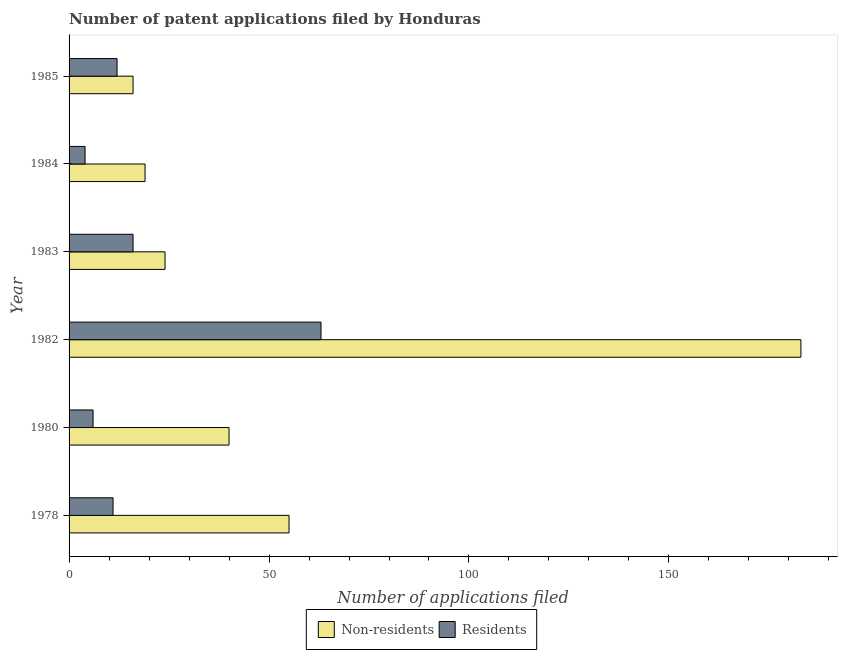How many different coloured bars are there?
Provide a succinct answer. 2. How many groups of bars are there?
Offer a very short reply. 6. How many bars are there on the 2nd tick from the bottom?
Offer a terse response. 2. In how many cases, is the number of bars for a given year not equal to the number of legend labels?
Provide a succinct answer. 0. What is the number of patent applications by non residents in 1984?
Your answer should be very brief. 19. Across all years, what is the maximum number of patent applications by non residents?
Make the answer very short. 183. Across all years, what is the minimum number of patent applications by residents?
Provide a succinct answer. 4. In which year was the number of patent applications by non residents minimum?
Your response must be concise. 1985. What is the total number of patent applications by residents in the graph?
Offer a very short reply. 112. What is the difference between the number of patent applications by residents in 1980 and that in 1985?
Keep it short and to the point. -6. What is the difference between the number of patent applications by residents in 1985 and the number of patent applications by non residents in 1983?
Your answer should be very brief. -12. What is the average number of patent applications by non residents per year?
Make the answer very short. 56.17. In the year 1984, what is the difference between the number of patent applications by non residents and number of patent applications by residents?
Your answer should be very brief. 15. What is the ratio of the number of patent applications by residents in 1982 to that in 1983?
Your response must be concise. 3.94. Is the number of patent applications by non residents in 1980 less than that in 1983?
Offer a very short reply. No. Is the difference between the number of patent applications by residents in 1982 and 1983 greater than the difference between the number of patent applications by non residents in 1982 and 1983?
Offer a very short reply. No. What is the difference between the highest and the lowest number of patent applications by non residents?
Your answer should be compact. 167. In how many years, is the number of patent applications by non residents greater than the average number of patent applications by non residents taken over all years?
Give a very brief answer. 1. What does the 2nd bar from the top in 1980 represents?
Offer a terse response. Non-residents. What does the 1st bar from the bottom in 1983 represents?
Your answer should be compact. Non-residents. How many bars are there?
Offer a terse response. 12. How many years are there in the graph?
Your answer should be very brief. 6. Does the graph contain any zero values?
Your answer should be very brief. No. Does the graph contain grids?
Make the answer very short. No. How many legend labels are there?
Give a very brief answer. 2. How are the legend labels stacked?
Provide a short and direct response. Horizontal. What is the title of the graph?
Your response must be concise. Number of patent applications filed by Honduras. Does "ODA received" appear as one of the legend labels in the graph?
Ensure brevity in your answer.  No. What is the label or title of the X-axis?
Offer a very short reply. Number of applications filed. What is the label or title of the Y-axis?
Give a very brief answer. Year. What is the Number of applications filed of Non-residents in 1978?
Give a very brief answer. 55. What is the Number of applications filed of Non-residents in 1980?
Your response must be concise. 40. What is the Number of applications filed of Non-residents in 1982?
Make the answer very short. 183. What is the Number of applications filed of Non-residents in 1983?
Provide a short and direct response. 24. What is the Number of applications filed in Residents in 1983?
Make the answer very short. 16. What is the Number of applications filed in Non-residents in 1985?
Your response must be concise. 16. What is the Number of applications filed of Residents in 1985?
Offer a very short reply. 12. Across all years, what is the maximum Number of applications filed of Non-residents?
Your answer should be compact. 183. Across all years, what is the minimum Number of applications filed of Non-residents?
Ensure brevity in your answer.  16. What is the total Number of applications filed in Non-residents in the graph?
Your answer should be compact. 337. What is the total Number of applications filed in Residents in the graph?
Give a very brief answer. 112. What is the difference between the Number of applications filed of Non-residents in 1978 and that in 1982?
Make the answer very short. -128. What is the difference between the Number of applications filed of Residents in 1978 and that in 1982?
Make the answer very short. -52. What is the difference between the Number of applications filed in Residents in 1978 and that in 1984?
Offer a very short reply. 7. What is the difference between the Number of applications filed in Non-residents in 1978 and that in 1985?
Your answer should be very brief. 39. What is the difference between the Number of applications filed of Residents in 1978 and that in 1985?
Give a very brief answer. -1. What is the difference between the Number of applications filed in Non-residents in 1980 and that in 1982?
Your answer should be compact. -143. What is the difference between the Number of applications filed of Residents in 1980 and that in 1982?
Offer a terse response. -57. What is the difference between the Number of applications filed in Non-residents in 1980 and that in 1983?
Your response must be concise. 16. What is the difference between the Number of applications filed of Residents in 1980 and that in 1984?
Your response must be concise. 2. What is the difference between the Number of applications filed in Non-residents in 1980 and that in 1985?
Make the answer very short. 24. What is the difference between the Number of applications filed in Non-residents in 1982 and that in 1983?
Offer a very short reply. 159. What is the difference between the Number of applications filed of Residents in 1982 and that in 1983?
Keep it short and to the point. 47. What is the difference between the Number of applications filed of Non-residents in 1982 and that in 1984?
Make the answer very short. 164. What is the difference between the Number of applications filed in Residents in 1982 and that in 1984?
Give a very brief answer. 59. What is the difference between the Number of applications filed in Non-residents in 1982 and that in 1985?
Offer a very short reply. 167. What is the difference between the Number of applications filed in Non-residents in 1983 and that in 1984?
Keep it short and to the point. 5. What is the difference between the Number of applications filed in Non-residents in 1983 and that in 1985?
Provide a short and direct response. 8. What is the difference between the Number of applications filed in Residents in 1983 and that in 1985?
Offer a terse response. 4. What is the difference between the Number of applications filed in Residents in 1984 and that in 1985?
Ensure brevity in your answer.  -8. What is the difference between the Number of applications filed in Non-residents in 1978 and the Number of applications filed in Residents in 1980?
Your response must be concise. 49. What is the difference between the Number of applications filed of Non-residents in 1980 and the Number of applications filed of Residents in 1983?
Keep it short and to the point. 24. What is the difference between the Number of applications filed of Non-residents in 1980 and the Number of applications filed of Residents in 1984?
Your response must be concise. 36. What is the difference between the Number of applications filed in Non-residents in 1980 and the Number of applications filed in Residents in 1985?
Your answer should be compact. 28. What is the difference between the Number of applications filed in Non-residents in 1982 and the Number of applications filed in Residents in 1983?
Provide a short and direct response. 167. What is the difference between the Number of applications filed of Non-residents in 1982 and the Number of applications filed of Residents in 1984?
Make the answer very short. 179. What is the difference between the Number of applications filed of Non-residents in 1982 and the Number of applications filed of Residents in 1985?
Give a very brief answer. 171. What is the difference between the Number of applications filed of Non-residents in 1984 and the Number of applications filed of Residents in 1985?
Provide a succinct answer. 7. What is the average Number of applications filed in Non-residents per year?
Your answer should be very brief. 56.17. What is the average Number of applications filed of Residents per year?
Provide a short and direct response. 18.67. In the year 1978, what is the difference between the Number of applications filed in Non-residents and Number of applications filed in Residents?
Offer a terse response. 44. In the year 1980, what is the difference between the Number of applications filed in Non-residents and Number of applications filed in Residents?
Make the answer very short. 34. In the year 1982, what is the difference between the Number of applications filed of Non-residents and Number of applications filed of Residents?
Keep it short and to the point. 120. In the year 1983, what is the difference between the Number of applications filed in Non-residents and Number of applications filed in Residents?
Keep it short and to the point. 8. What is the ratio of the Number of applications filed of Non-residents in 1978 to that in 1980?
Your answer should be very brief. 1.38. What is the ratio of the Number of applications filed in Residents in 1978 to that in 1980?
Provide a succinct answer. 1.83. What is the ratio of the Number of applications filed of Non-residents in 1978 to that in 1982?
Make the answer very short. 0.3. What is the ratio of the Number of applications filed in Residents in 1978 to that in 1982?
Your response must be concise. 0.17. What is the ratio of the Number of applications filed of Non-residents in 1978 to that in 1983?
Make the answer very short. 2.29. What is the ratio of the Number of applications filed of Residents in 1978 to that in 1983?
Your answer should be compact. 0.69. What is the ratio of the Number of applications filed of Non-residents in 1978 to that in 1984?
Keep it short and to the point. 2.89. What is the ratio of the Number of applications filed in Residents in 1978 to that in 1984?
Give a very brief answer. 2.75. What is the ratio of the Number of applications filed of Non-residents in 1978 to that in 1985?
Provide a succinct answer. 3.44. What is the ratio of the Number of applications filed in Residents in 1978 to that in 1985?
Your answer should be compact. 0.92. What is the ratio of the Number of applications filed in Non-residents in 1980 to that in 1982?
Keep it short and to the point. 0.22. What is the ratio of the Number of applications filed of Residents in 1980 to that in 1982?
Keep it short and to the point. 0.1. What is the ratio of the Number of applications filed in Non-residents in 1980 to that in 1983?
Your response must be concise. 1.67. What is the ratio of the Number of applications filed of Non-residents in 1980 to that in 1984?
Make the answer very short. 2.11. What is the ratio of the Number of applications filed in Residents in 1980 to that in 1984?
Offer a very short reply. 1.5. What is the ratio of the Number of applications filed of Non-residents in 1982 to that in 1983?
Give a very brief answer. 7.62. What is the ratio of the Number of applications filed of Residents in 1982 to that in 1983?
Keep it short and to the point. 3.94. What is the ratio of the Number of applications filed of Non-residents in 1982 to that in 1984?
Your response must be concise. 9.63. What is the ratio of the Number of applications filed of Residents in 1982 to that in 1984?
Keep it short and to the point. 15.75. What is the ratio of the Number of applications filed of Non-residents in 1982 to that in 1985?
Offer a terse response. 11.44. What is the ratio of the Number of applications filed of Residents in 1982 to that in 1985?
Your answer should be very brief. 5.25. What is the ratio of the Number of applications filed of Non-residents in 1983 to that in 1984?
Your response must be concise. 1.26. What is the ratio of the Number of applications filed of Residents in 1983 to that in 1984?
Provide a succinct answer. 4. What is the ratio of the Number of applications filed of Non-residents in 1983 to that in 1985?
Ensure brevity in your answer.  1.5. What is the ratio of the Number of applications filed in Residents in 1983 to that in 1985?
Provide a succinct answer. 1.33. What is the ratio of the Number of applications filed of Non-residents in 1984 to that in 1985?
Offer a terse response. 1.19. What is the difference between the highest and the second highest Number of applications filed in Non-residents?
Offer a very short reply. 128. What is the difference between the highest and the second highest Number of applications filed in Residents?
Make the answer very short. 47. What is the difference between the highest and the lowest Number of applications filed of Non-residents?
Your answer should be very brief. 167. 